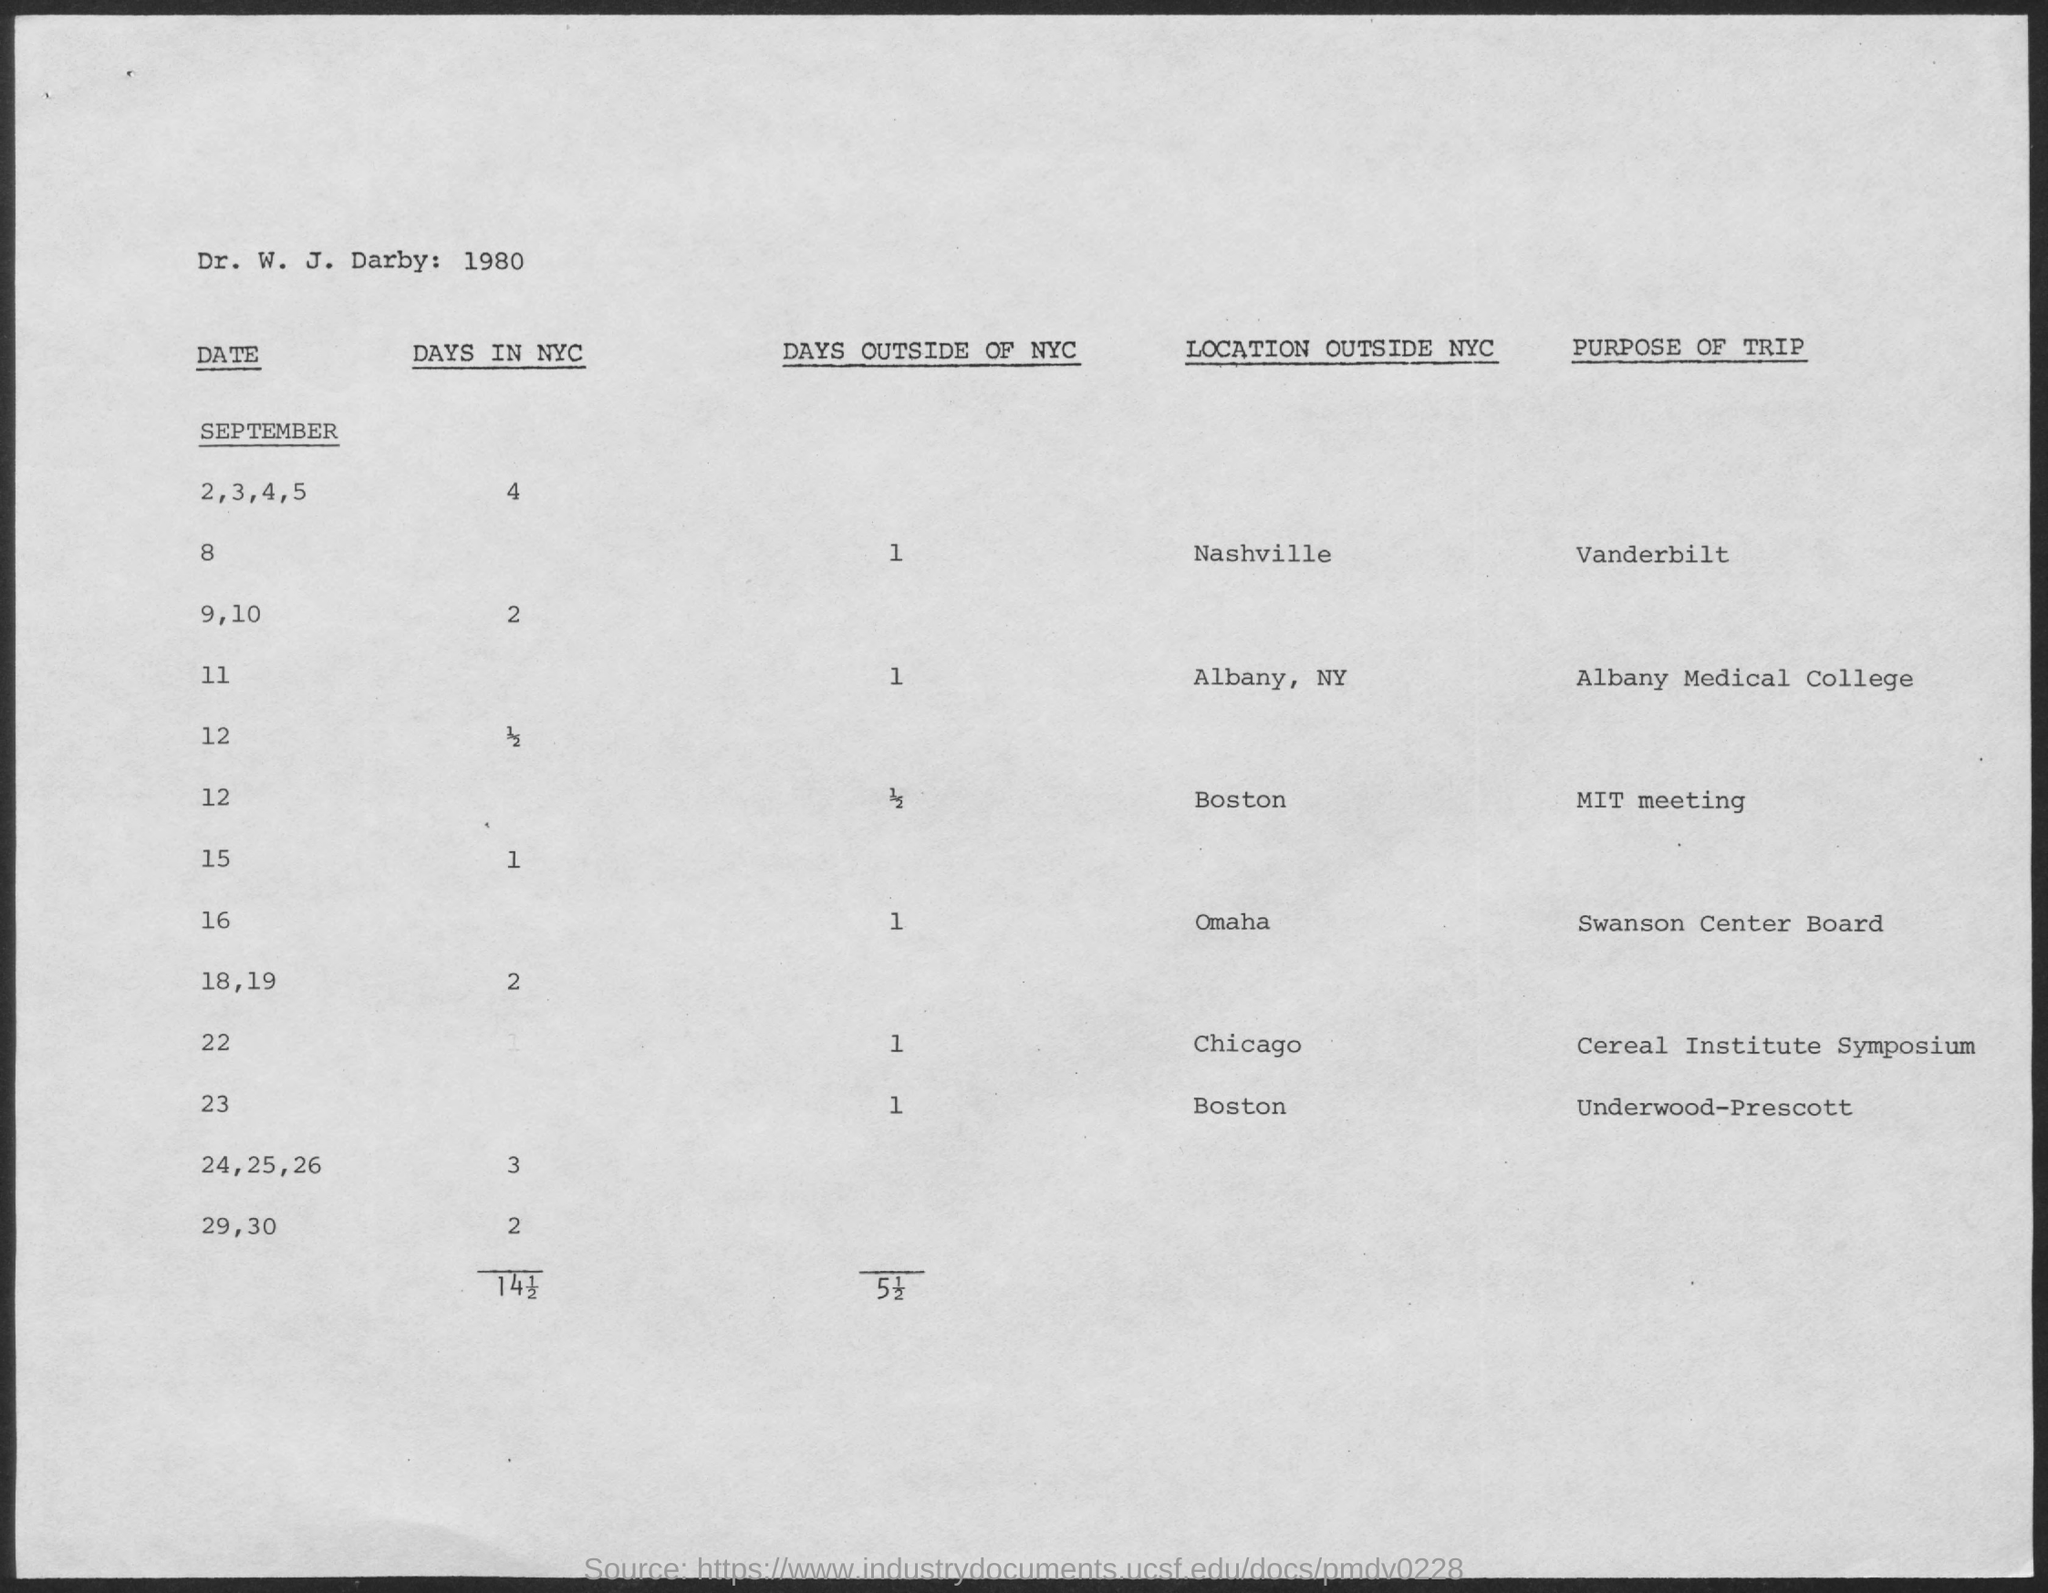What are the number of Days in NYC for September 2,3,4,5?
Provide a short and direct response. 4. What are the number of Days in NYC for September 9,10?
Offer a very short reply. 2. What are the number of Days in NYC for September 15?
Ensure brevity in your answer.  1. What are the number of Days in NYC for September 18,19?
Your answer should be very brief. 2. What are the number of Days in NYC for September 24,25,26?
Your answer should be very brief. 3. What are the number of Days in NYC for September 29,30?
Provide a succinct answer. 2. What are the number of Days outside of NYC for September 8?
Provide a short and direct response. 1. What are the number of Days outside of NYC for September 11?
Your response must be concise. 1. What are the number of Days outside of NYC for September 16?
Keep it short and to the point. 1. 